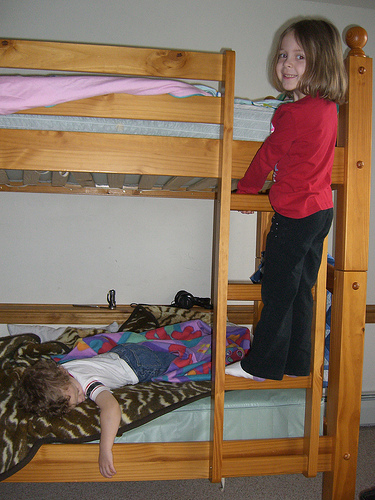<image>
Can you confirm if the kid is under the bed? No. The kid is not positioned under the bed. The vertical relationship between these objects is different. Is the girl in the bed? No. The girl is not contained within the bed. These objects have a different spatial relationship. Is there a bed in front of the wall? Yes. The bed is positioned in front of the wall, appearing closer to the camera viewpoint. 